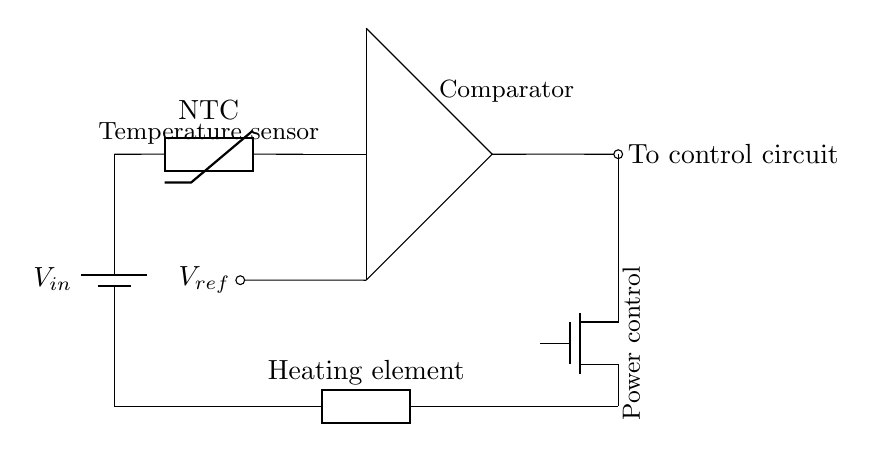What component is used to sense temperature? The circuit includes a thermistor labeled as NTC, which is commonly used to measure temperature due to its resistance change with temperature variation.
Answer: Thermistor What type of MOSFET is shown in the circuit? The circuit depicts a N-channel MOSFET, indicated by the label "Tnmos." This type of transistor is typically used for switching applications, particularly in power control.
Answer: N-channel What is the purpose of the comparator in this circuit? The comparator compares the temperature reading from the thermistor with a reference voltage. Its output determines if the heating element should be activated or deactivated based on the sensed temperature.
Answer: Control heating element What is the role of the reference voltage in the circuit? The reference voltage serves as the threshold that the comparator uses to decide when the output should change, allowing the system to activate or deactivate the heating element based on the temperature detected by the thermistor.
Answer: Set temperature threshold How does the heating element connect to the overall circuit? The heating element is directly connected in series with the power supply, and it is controlled by the output from the MOSFET, which is turned on or off by the comparator based on the temperature reading.
Answer: In series with power supply At what point is the output directed in the circuit? The output from the comparator is directed to control the circuit, specifically influencing the operation of the heating element through the MOSFET.
Answer: To control circuit 